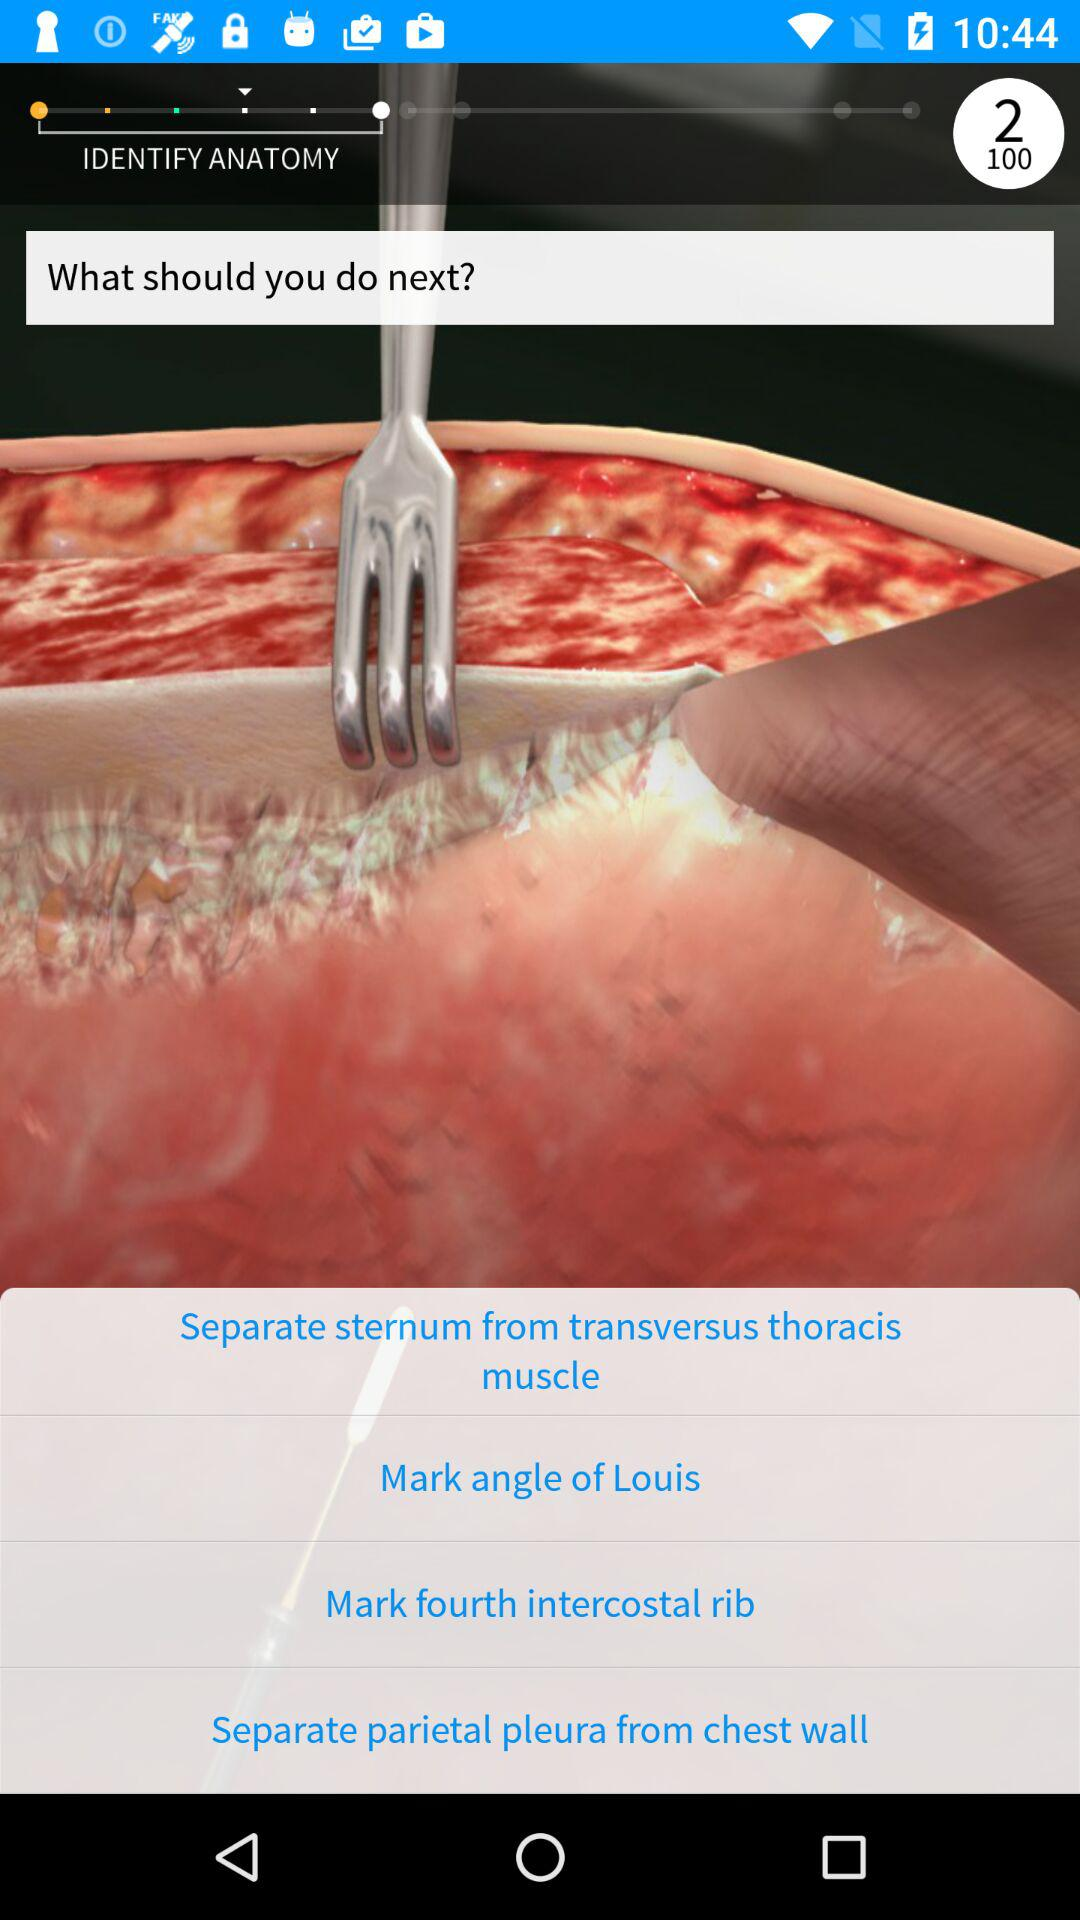What to do next?
When the provided information is insufficient, respond with <no answer>. <no answer> 